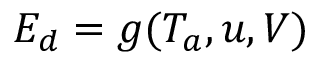<formula> <loc_0><loc_0><loc_500><loc_500>E _ { d } = g ( T _ { a } , u , V )</formula> 